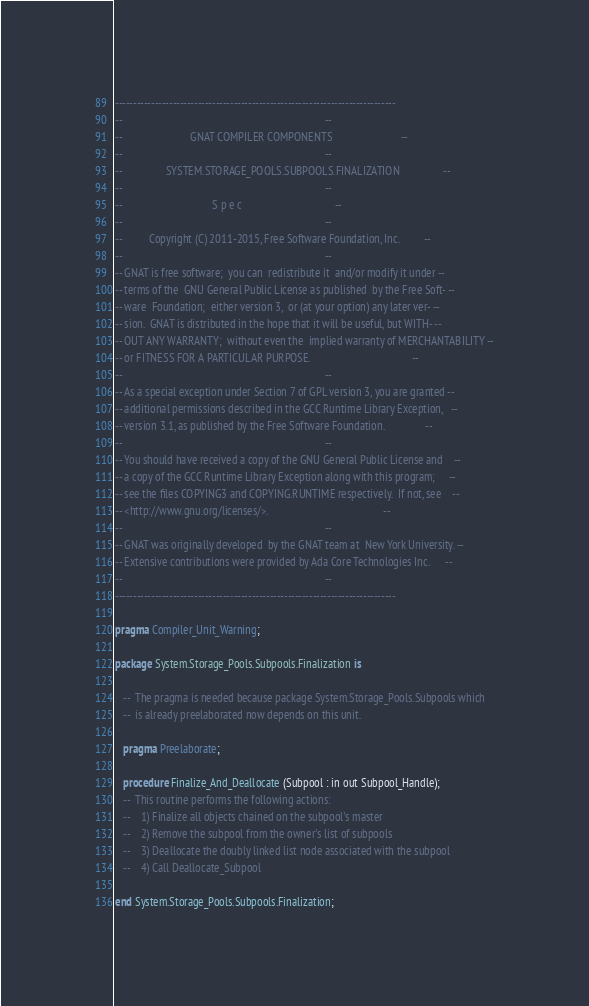<code> <loc_0><loc_0><loc_500><loc_500><_Ada_>------------------------------------------------------------------------------
--                                                                          --
--                         GNAT COMPILER COMPONENTS                         --
--                                                                          --
--                SYSTEM.STORAGE_POOLS.SUBPOOLS.FINALIZATION                --
--                                                                          --
--                                 S p e c                                  --
--                                                                          --
--          Copyright (C) 2011-2015, Free Software Foundation, Inc.         --
--                                                                          --
-- GNAT is free software;  you can  redistribute it  and/or modify it under --
-- terms of the  GNU General Public License as published  by the Free Soft- --
-- ware  Foundation;  either version 3,  or (at your option) any later ver- --
-- sion.  GNAT is distributed in the hope that it will be useful, but WITH- --
-- OUT ANY WARRANTY;  without even the  implied warranty of MERCHANTABILITY --
-- or FITNESS FOR A PARTICULAR PURPOSE.                                     --
--                                                                          --
-- As a special exception under Section 7 of GPL version 3, you are granted --
-- additional permissions described in the GCC Runtime Library Exception,   --
-- version 3.1, as published by the Free Software Foundation.               --
--                                                                          --
-- You should have received a copy of the GNU General Public License and    --
-- a copy of the GCC Runtime Library Exception along with this program;     --
-- see the files COPYING3 and COPYING.RUNTIME respectively.  If not, see    --
-- <http://www.gnu.org/licenses/>.                                          --
--                                                                          --
-- GNAT was originally developed  by the GNAT team at  New York University. --
-- Extensive contributions were provided by Ada Core Technologies Inc.      --
--                                                                          --
------------------------------------------------------------------------------

pragma Compiler_Unit_Warning;

package System.Storage_Pools.Subpools.Finalization is

   --  The pragma is needed because package System.Storage_Pools.Subpools which
   --  is already preelaborated now depends on this unit.

   pragma Preelaborate;

   procedure Finalize_And_Deallocate (Subpool : in out Subpool_Handle);
   --  This routine performs the following actions:
   --    1) Finalize all objects chained on the subpool's master
   --    2) Remove the subpool from the owner's list of subpools
   --    3) Deallocate the doubly linked list node associated with the subpool
   --    4) Call Deallocate_Subpool

end System.Storage_Pools.Subpools.Finalization;
</code> 